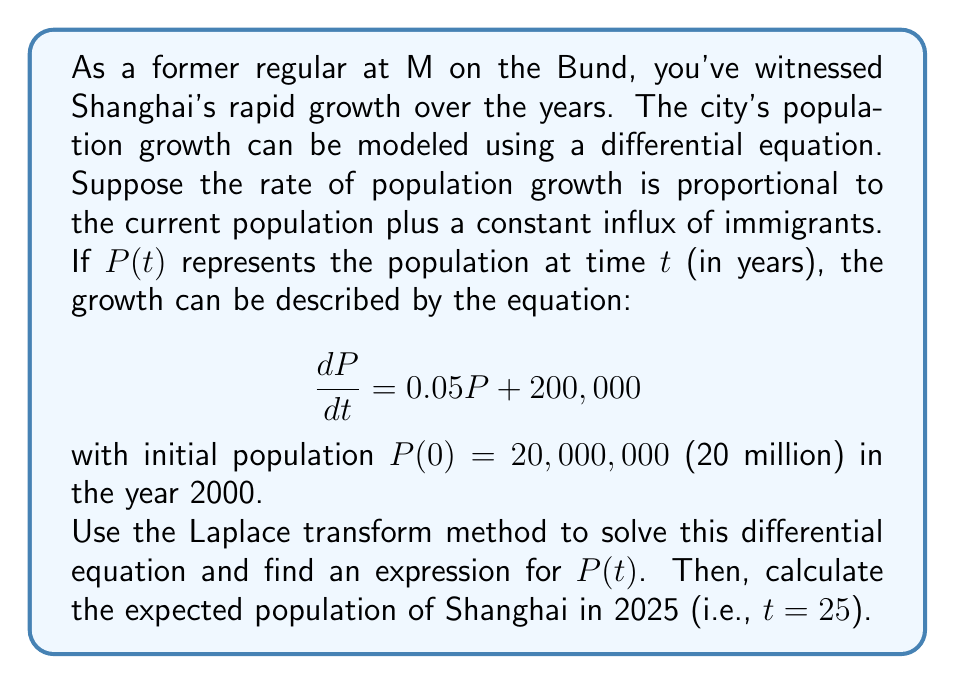What is the answer to this math problem? Let's solve this problem step by step using the Laplace transform method:

1) First, we take the Laplace transform of both sides of the differential equation:

   $$\mathcal{L}\left\{\frac{dP}{dt}\right\} = \mathcal{L}\{0.05P + 200,000\}$$

2) Using the linearity property and the Laplace transform of a constant:

   $$s\mathcal{L}\{P\} - P(0) = 0.05\mathcal{L}\{P\} + \frac{200,000}{s}$$

3) Let $\mathcal{L}\{P\} = F(s)$. Substituting the initial condition $P(0) = 20,000,000$:

   $$sF(s) - 20,000,000 = 0.05F(s) + \frac{200,000}{s}$$

4) Rearranging the equation:

   $$(s - 0.05)F(s) = 20,000,000 + \frac{200,000}{s}$$

5) Solving for $F(s)$:

   $$F(s) = \frac{20,000,000}{s - 0.05} + \frac{200,000}{s(s - 0.05)}$$

6) Using partial fraction decomposition:

   $$F(s) = \frac{20,000,000}{s - 0.05} + \frac{4,000,000}{s} - \frac{4,000,000}{s - 0.05}$$

7) Taking the inverse Laplace transform:

   $$P(t) = 20,000,000e^{0.05t} + 4,000,000 - 4,000,000e^{0.05t}$$

8) Simplifying:

   $$P(t) = 16,000,000e^{0.05t} + 4,000,000$$

9) To find the population in 2025 (t = 25):

   $$P(25) = 16,000,000e^{0.05(25)} + 4,000,000$$
   $$= 16,000,000e^{1.25} + 4,000,000$$
   $$\approx 55,933,895$$

Therefore, the expected population of Shanghai in 2025 is approximately 55,933,895 people.
Answer: The population of Shanghai at time $t$ is given by:

$$P(t) = 16,000,000e^{0.05t} + 4,000,000$$

The expected population in 2025 (t = 25) is approximately 55,933,895 people. 